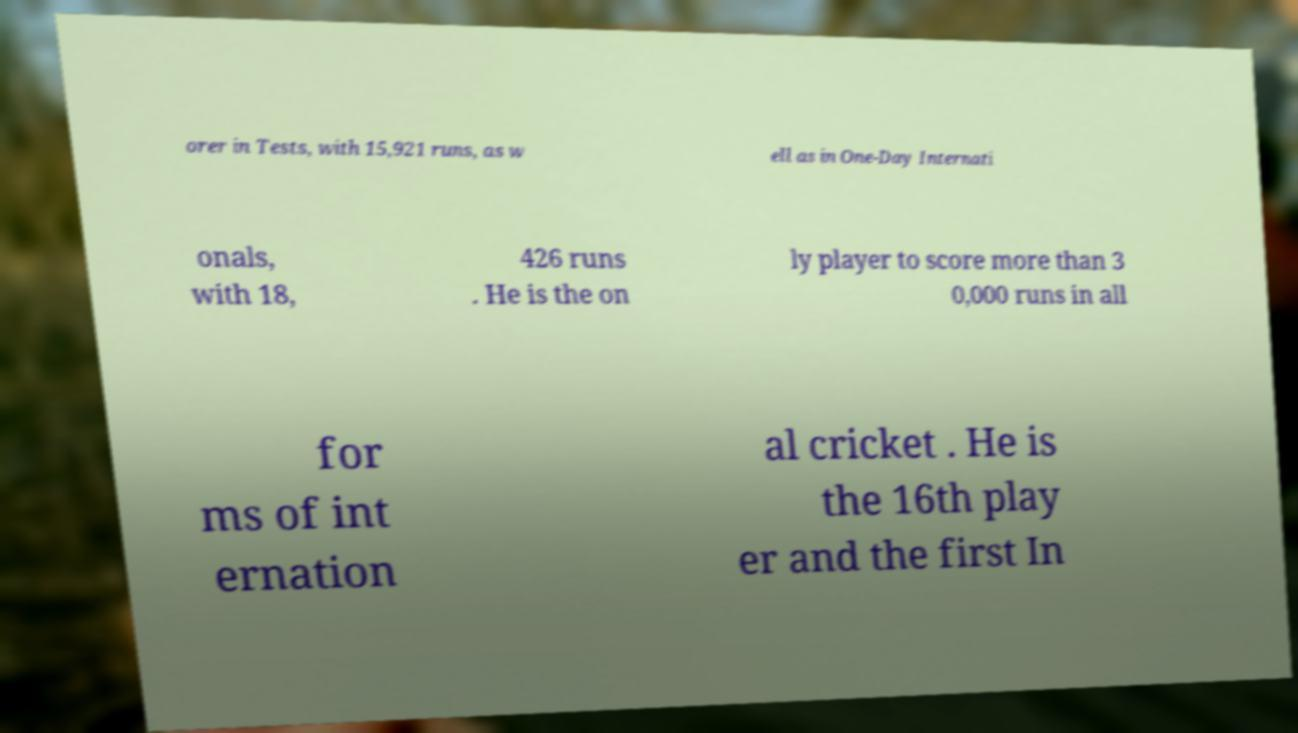Please identify and transcribe the text found in this image. orer in Tests, with 15,921 runs, as w ell as in One-Day Internati onals, with 18, 426 runs . He is the on ly player to score more than 3 0,000 runs in all for ms of int ernation al cricket . He is the 16th play er and the first In 